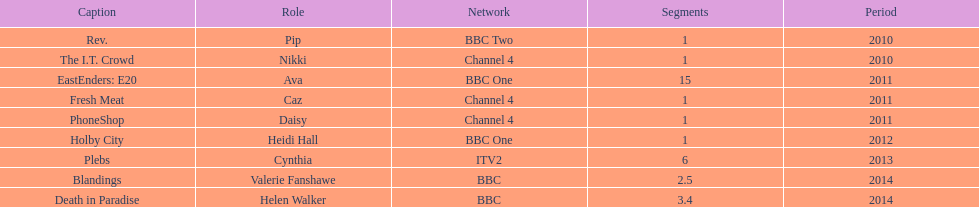Give me the full table as a dictionary. {'header': ['Caption', 'Role', 'Network', 'Segments', 'Period'], 'rows': [['Rev.', 'Pip', 'BBC Two', '1', '2010'], ['The I.T. Crowd', 'Nikki', 'Channel 4', '1', '2010'], ['EastEnders: E20', 'Ava', 'BBC One', '15', '2011'], ['Fresh Meat', 'Caz', 'Channel 4', '1', '2011'], ['PhoneShop', 'Daisy', 'Channel 4', '1', '2011'], ['Holby City', 'Heidi Hall', 'BBC One', '1', '2012'], ['Plebs', 'Cynthia', 'ITV2', '6', '2013'], ['Blandings', 'Valerie Fanshawe', 'BBC', '2.5', '2014'], ['Death in Paradise', 'Helen Walker', 'BBC', '3.4', '2014']]} How many titles have at least 5 episodes? 2. 